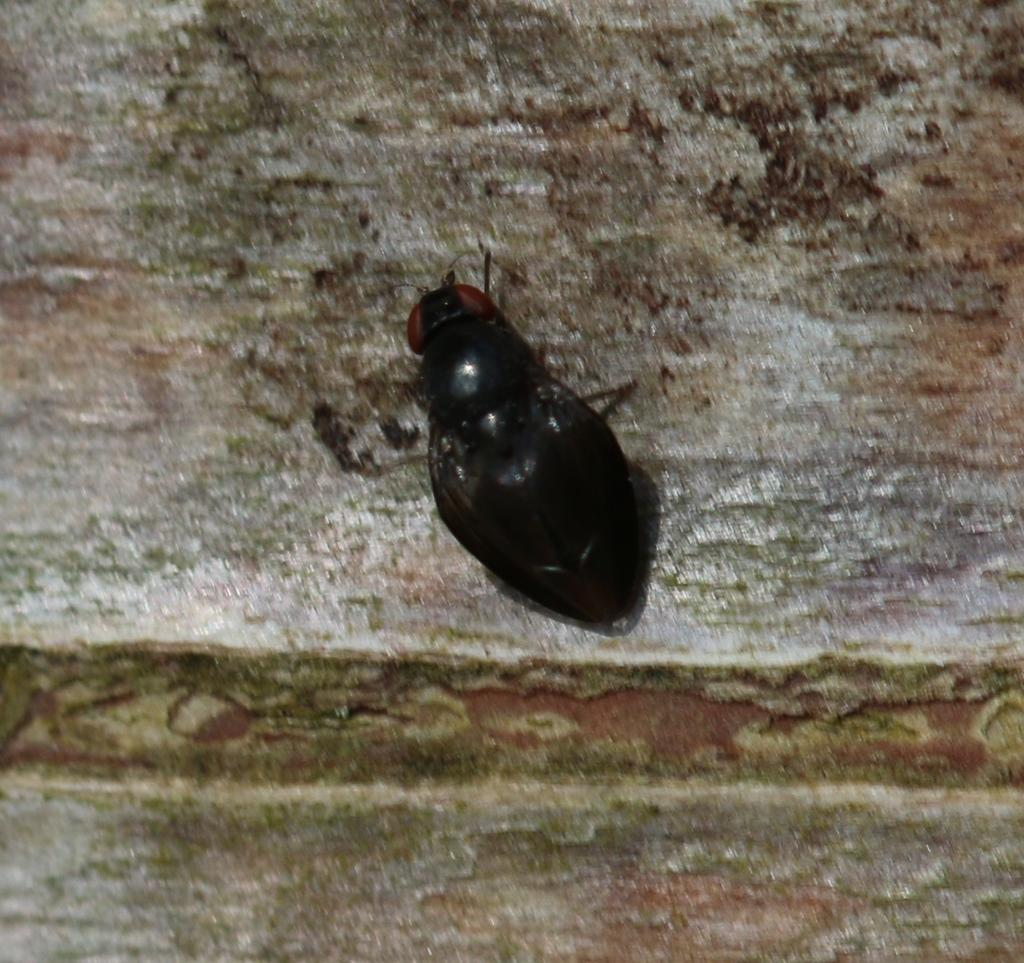What type of creature is in the image? There is an insect in the image. Where is the insect located in the image? The insect is standing on the floor. What type of snow can be seen falling in the image? There is no snow present in the image; it features an insect standing on the floor. How does the insect use the brake in the image? Insects do not have brakes, as they are not vehicles or machines. 